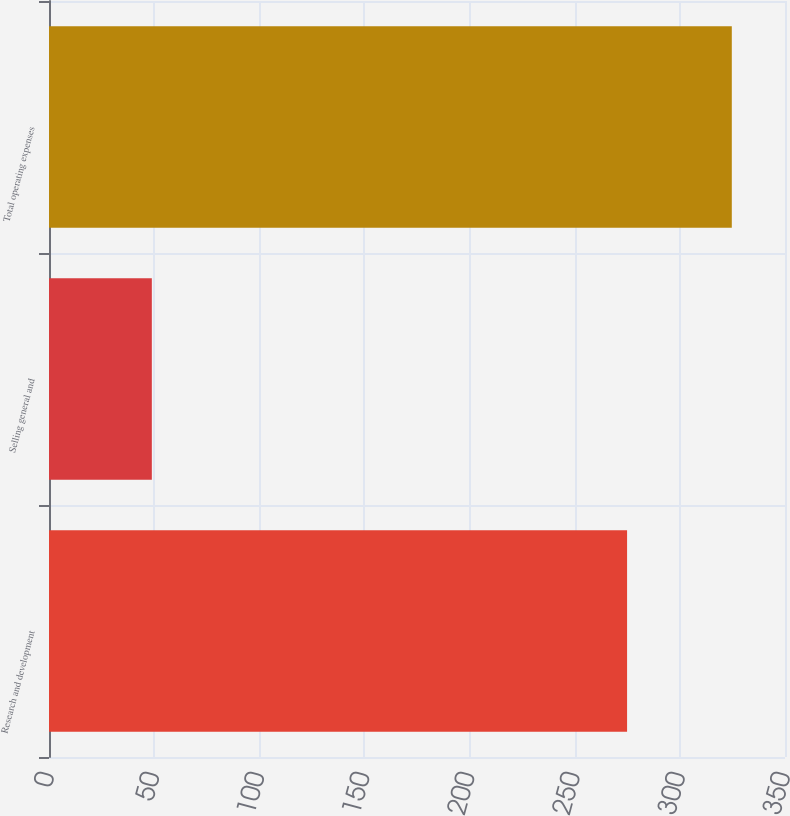<chart> <loc_0><loc_0><loc_500><loc_500><bar_chart><fcel>Research and development<fcel>Selling general and<fcel>Total operating expenses<nl><fcel>274.9<fcel>48.9<fcel>324.7<nl></chart> 